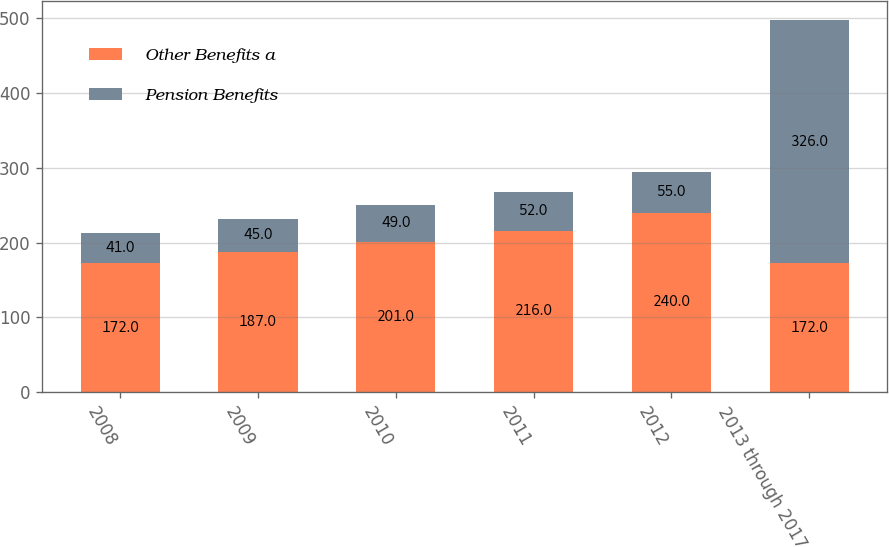Convert chart to OTSL. <chart><loc_0><loc_0><loc_500><loc_500><stacked_bar_chart><ecel><fcel>2008<fcel>2009<fcel>2010<fcel>2011<fcel>2012<fcel>2013 through 2017<nl><fcel>Other Benefits a<fcel>172<fcel>187<fcel>201<fcel>216<fcel>240<fcel>172<nl><fcel>Pension Benefits<fcel>41<fcel>45<fcel>49<fcel>52<fcel>55<fcel>326<nl></chart> 